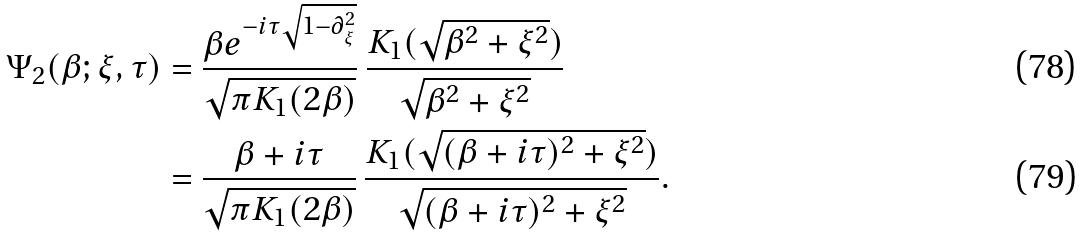Convert formula to latex. <formula><loc_0><loc_0><loc_500><loc_500>\Psi _ { 2 } ( \beta ; \xi , \tau ) & = \frac { \beta e ^ { - i \tau \sqrt { 1 - \partial _ { \xi } ^ { 2 } } } } { \sqrt { \pi K _ { 1 } ( 2 \beta ) } } \, \frac { K _ { 1 } ( \sqrt { \beta ^ { 2 } + \xi ^ { 2 } } ) } { \sqrt { \beta ^ { 2 } + \xi ^ { 2 } } } \\ & = \frac { \beta + i \tau } { \sqrt { \pi K _ { 1 } ( 2 \beta ) } } \, \frac { K _ { 1 } ( \sqrt { ( \beta + i \tau ) ^ { 2 } + \xi ^ { 2 } } ) } { \sqrt { ( \beta + i \tau ) ^ { 2 } + \xi ^ { 2 } } } .</formula> 